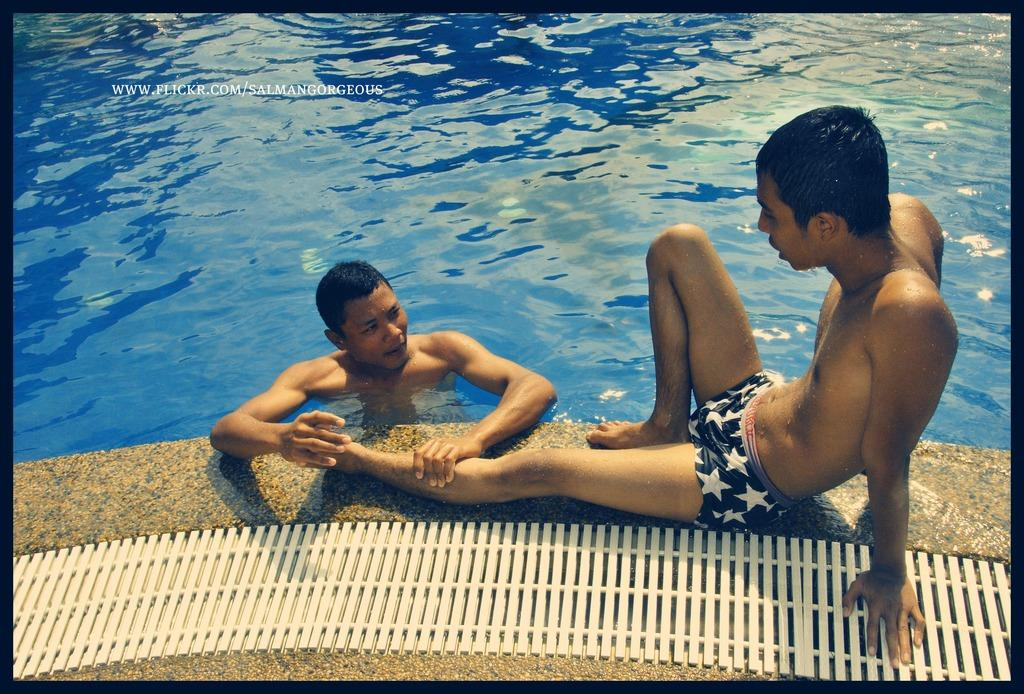What is the main subject of the image? There is a person in a swimming pool in the image. Are there any other people in the image? Yes, there is another person sitting on the floor in the image. Can you describe any text visible in the image? There is text visible on the photo. How does the creator of the image experience the earthquake while taking the photo? There is no mention of an earthquake in the image or the facts provided, so it cannot be determined if the creator experienced an earthquake while taking the photo. 